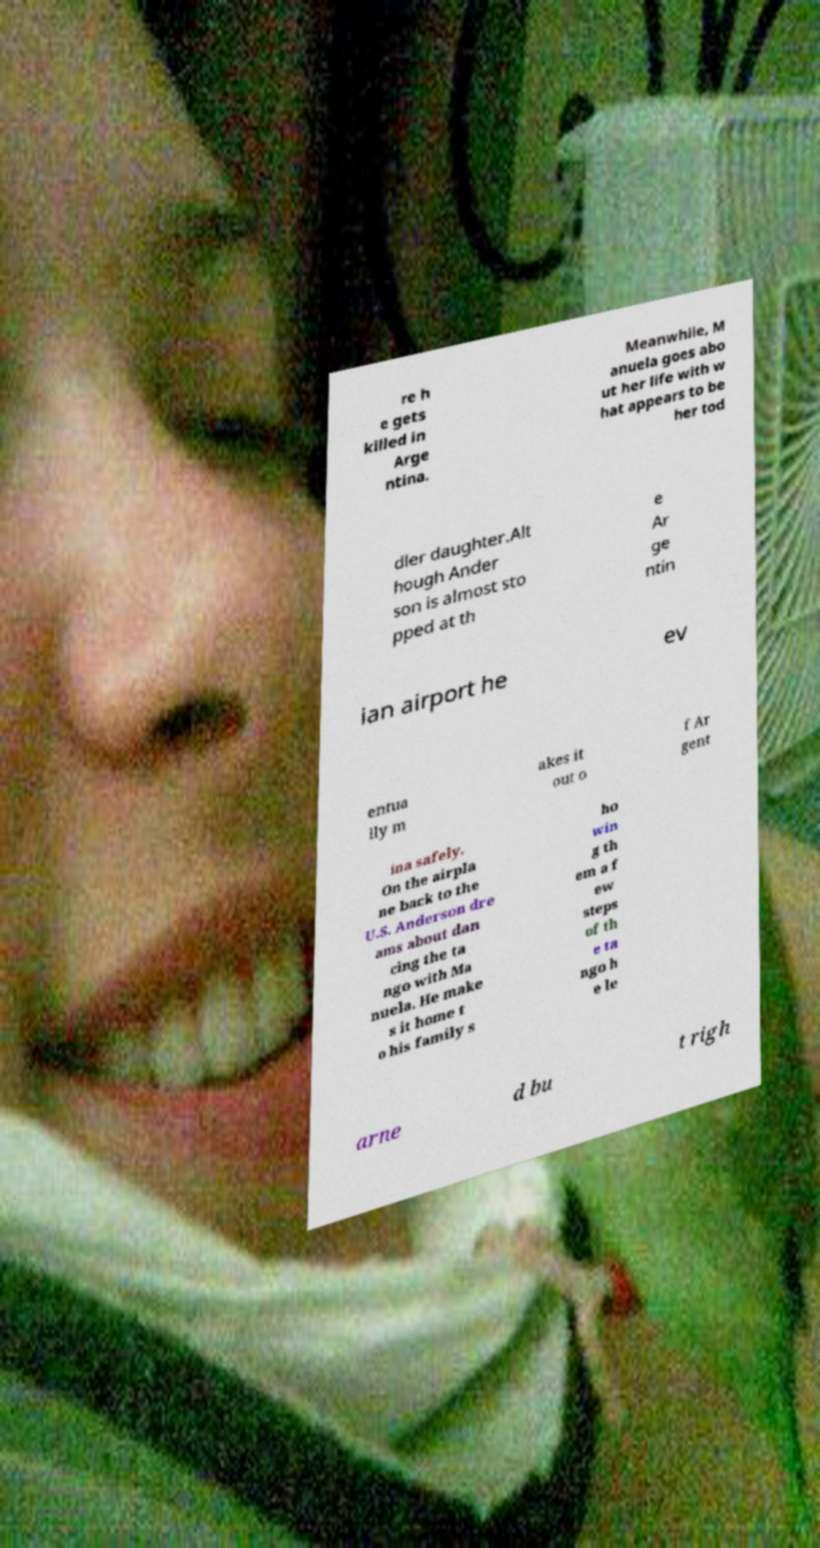There's text embedded in this image that I need extracted. Can you transcribe it verbatim? re h e gets killed in Arge ntina. Meanwhile, M anuela goes abo ut her life with w hat appears to be her tod dler daughter.Alt hough Ander son is almost sto pped at th e Ar ge ntin ian airport he ev entua lly m akes it out o f Ar gent ina safely. On the airpla ne back to the U.S. Anderson dre ams about dan cing the ta ngo with Ma nuela. He make s it home t o his family s ho win g th em a f ew steps of th e ta ngo h e le arne d bu t righ 